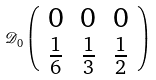<formula> <loc_0><loc_0><loc_500><loc_500>\mathcal { D } _ { 0 } \left ( \begin{array} { c c c } 0 & 0 & 0 \\ \frac { 1 } { 6 } & \frac { 1 } { 3 } & \frac { 1 } { 2 } \end{array} \right )</formula> 